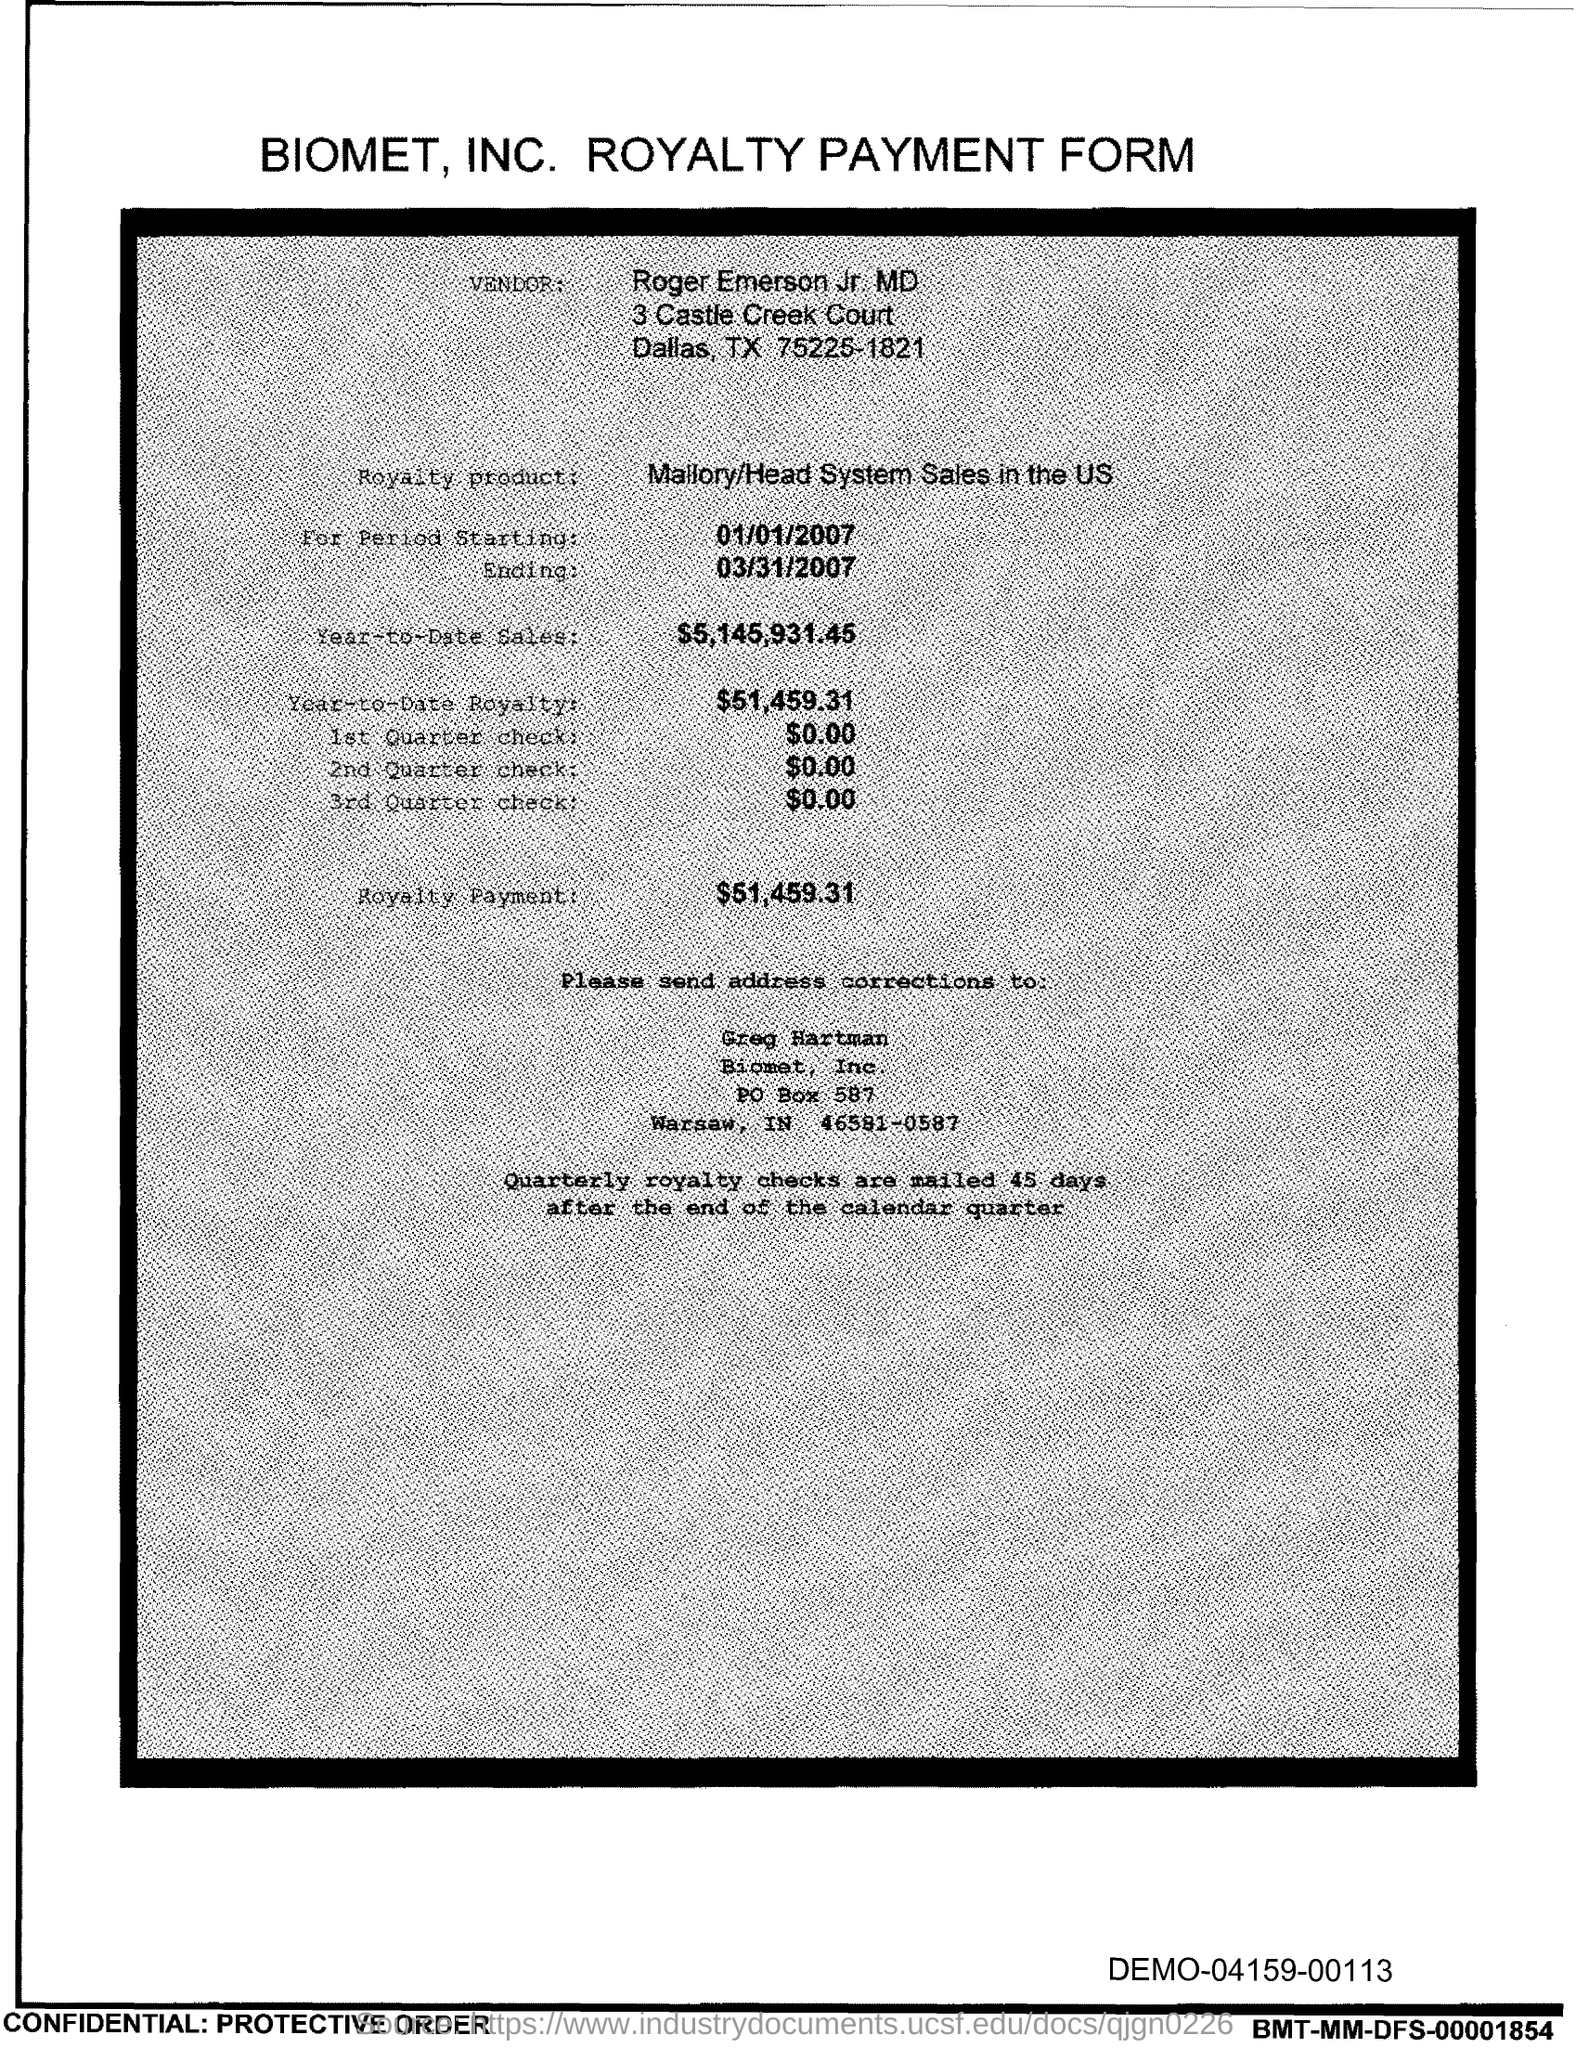What is the po box no. of biomet, inc.?
Provide a short and direct response. 587. What is the date for period  starting?
Your answer should be very brief. 01/01/2007. What is the date for ending ?
Your response must be concise. 03/31/2007. What is the year-to-date sales?
Give a very brief answer. $5,145,931.45. What is the year-to-date royalty ?
Ensure brevity in your answer.  $51,459.31. What is the royalty payment ?
Provide a succinct answer. $51,459.31. 